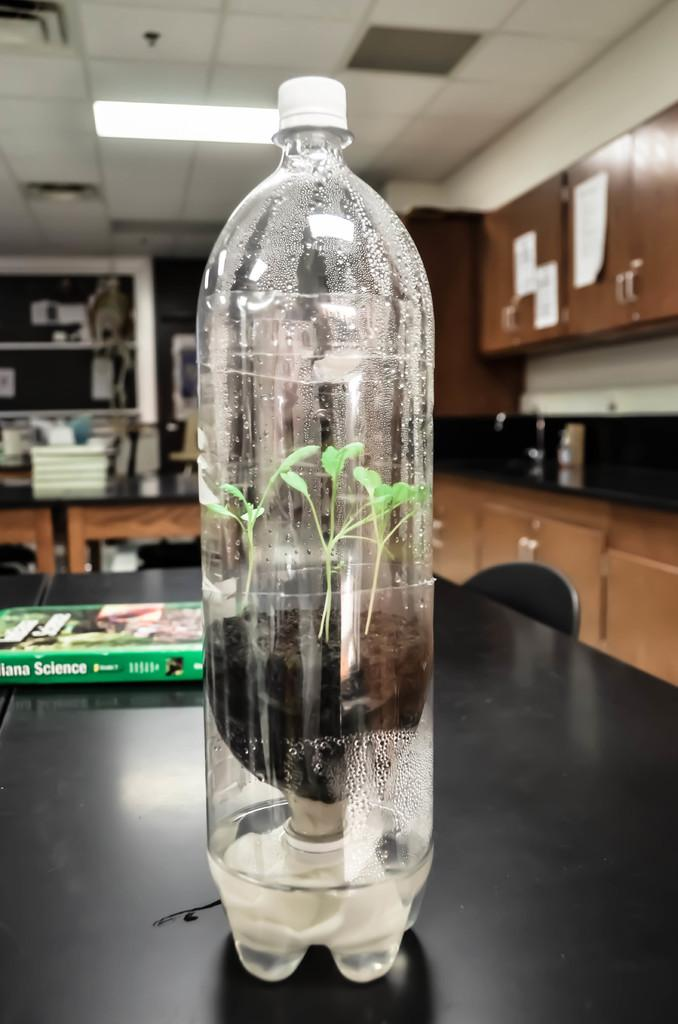What object is placed on the table in the image? There is a bottle on the table. What is unique about the plant in the image? The plant is inside the bottle. What else can be seen on the table in the image? There is a book on the table. Can you see any snow in the image? There is no snow present in the image. What type of animals can be seen at the zoo in the image? There is no zoo or animals present in the image. How many cherries are on top of the book in the image? There are no cherries present in the image. 